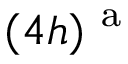<formula> <loc_0><loc_0><loc_500><loc_500>( 4 h ) ^ { a }</formula> 